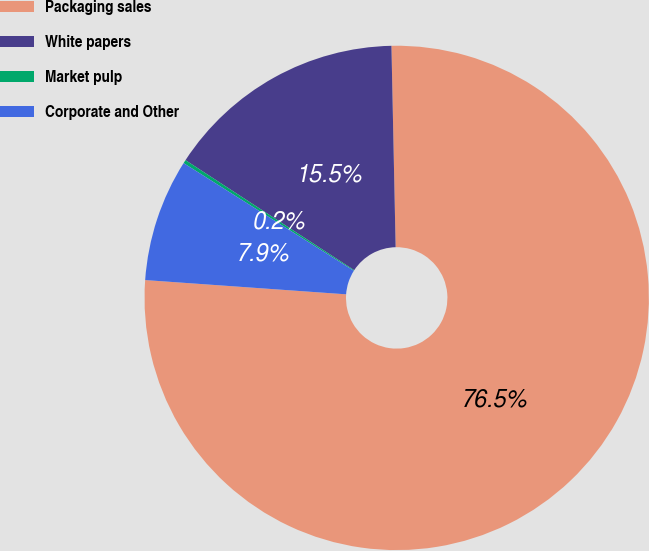<chart> <loc_0><loc_0><loc_500><loc_500><pie_chart><fcel>Packaging sales<fcel>White papers<fcel>Market pulp<fcel>Corporate and Other<nl><fcel>76.46%<fcel>15.47%<fcel>0.22%<fcel>7.85%<nl></chart> 